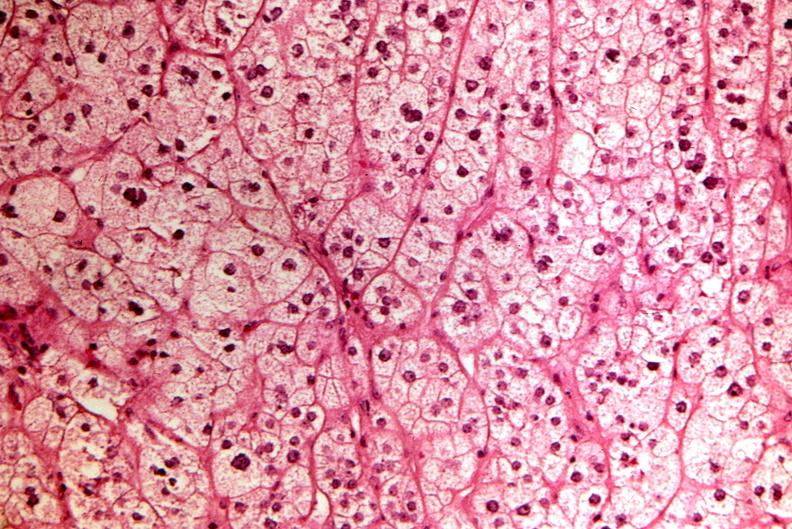does this image show pituitary, chromaphobe adenoma?
Answer the question using a single word or phrase. Yes 